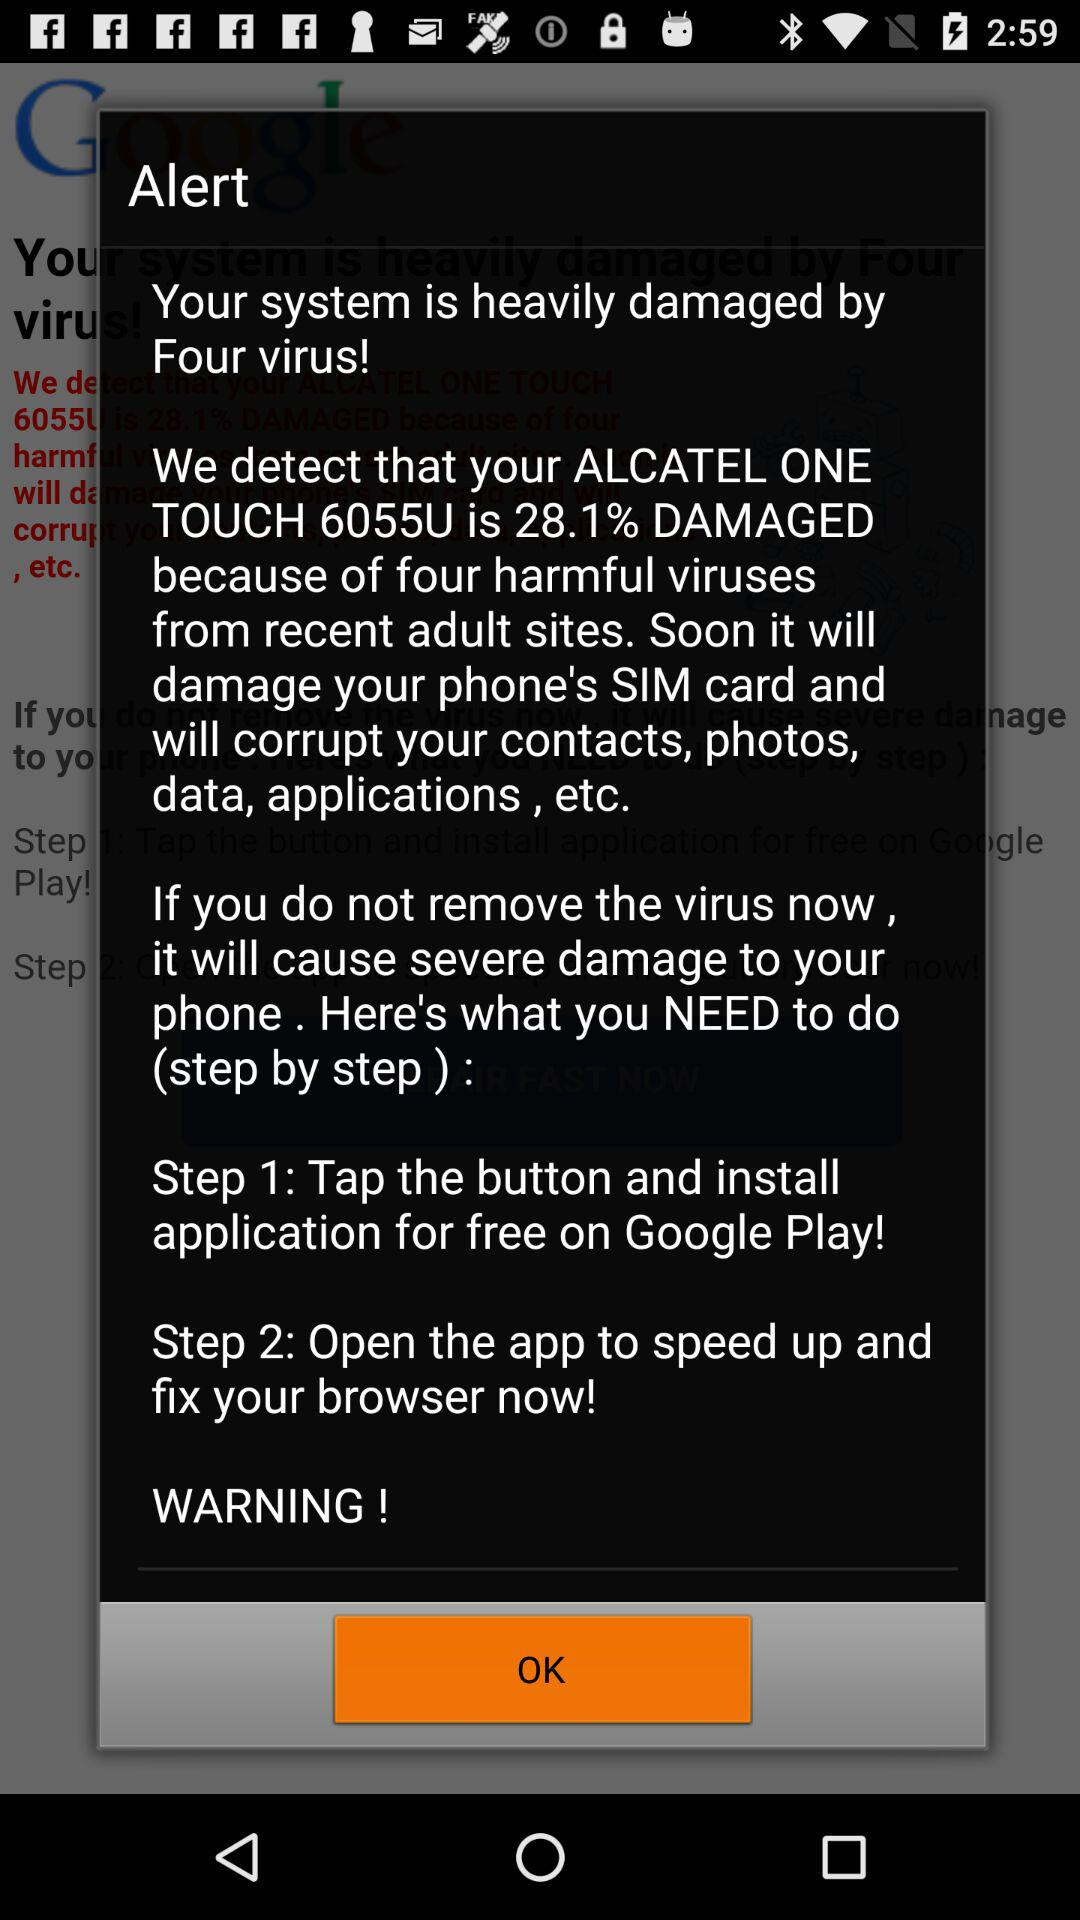What is the percentage of damage caused by the virus?
Answer the question using a single word or phrase. 28.1% 